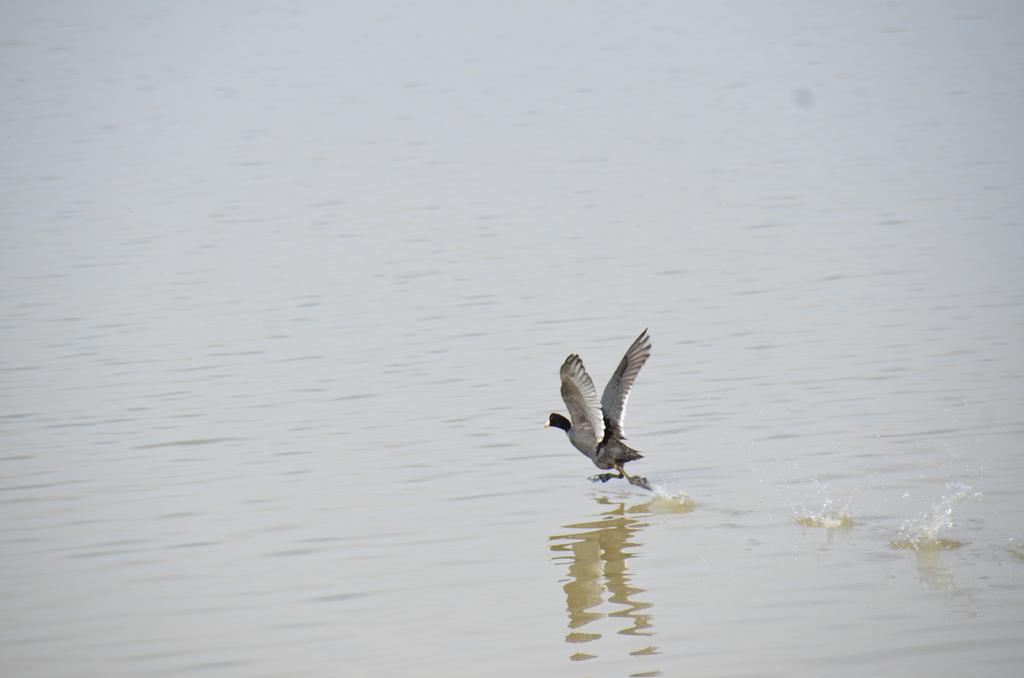What type of animal is present in the image? There is a bird in the image. What is the bird doing in the image? The bird is flying. What can be seen at the bottom of the image? There is water visible at the bottom of the image. What type of sand can be seen on the table in the image? There is no sand or table present in the image; it features a bird flying over water. 